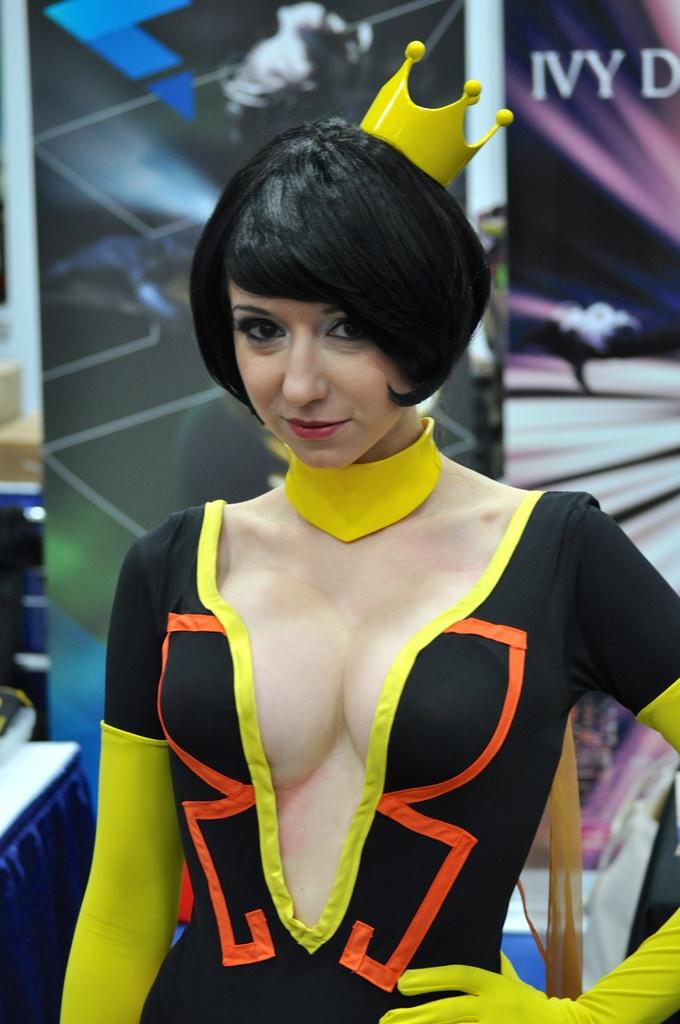What is the 3 letter work in the background?
Ensure brevity in your answer.  Ivy. 